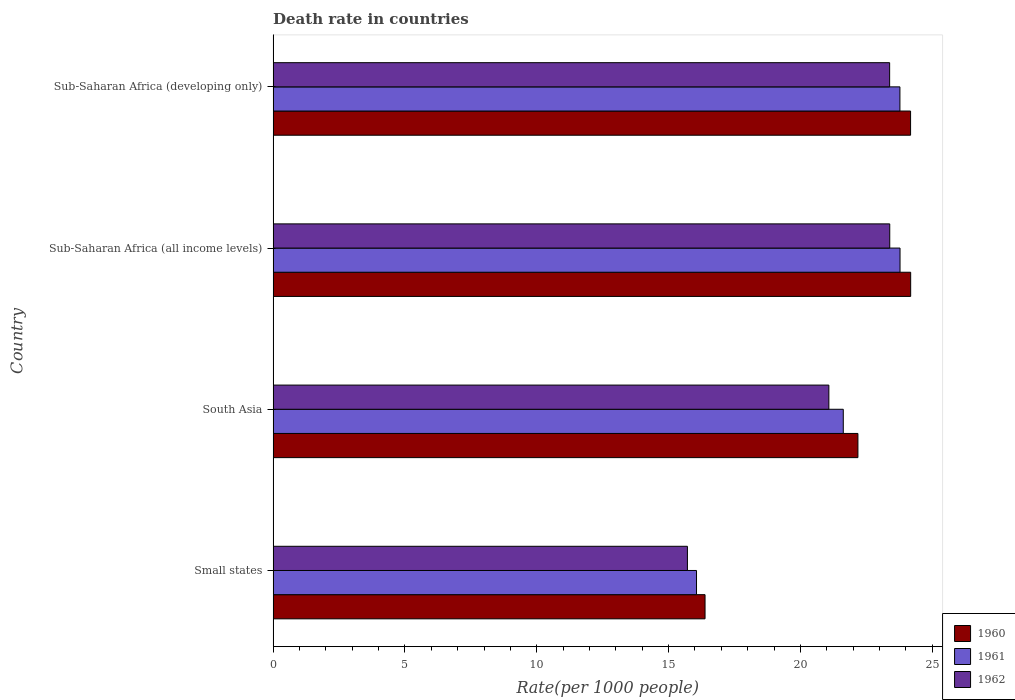How many different coloured bars are there?
Provide a succinct answer. 3. How many groups of bars are there?
Give a very brief answer. 4. Are the number of bars on each tick of the Y-axis equal?
Make the answer very short. Yes. How many bars are there on the 1st tick from the top?
Give a very brief answer. 3. How many bars are there on the 1st tick from the bottom?
Give a very brief answer. 3. What is the label of the 2nd group of bars from the top?
Provide a succinct answer. Sub-Saharan Africa (all income levels). What is the death rate in 1962 in Small states?
Your response must be concise. 15.72. Across all countries, what is the maximum death rate in 1960?
Your answer should be very brief. 24.18. Across all countries, what is the minimum death rate in 1961?
Offer a very short reply. 16.06. In which country was the death rate in 1961 maximum?
Offer a very short reply. Sub-Saharan Africa (all income levels). In which country was the death rate in 1960 minimum?
Ensure brevity in your answer.  Small states. What is the total death rate in 1962 in the graph?
Your answer should be compact. 83.58. What is the difference between the death rate in 1960 in South Asia and that in Sub-Saharan Africa (developing only)?
Provide a succinct answer. -2. What is the difference between the death rate in 1962 in Sub-Saharan Africa (all income levels) and the death rate in 1961 in Small states?
Keep it short and to the point. 7.33. What is the average death rate in 1961 per country?
Make the answer very short. 21.31. What is the difference between the death rate in 1960 and death rate in 1961 in Sub-Saharan Africa (all income levels)?
Ensure brevity in your answer.  0.4. What is the ratio of the death rate in 1962 in Small states to that in Sub-Saharan Africa (all income levels)?
Your answer should be very brief. 0.67. What is the difference between the highest and the second highest death rate in 1962?
Provide a succinct answer. 0. What is the difference between the highest and the lowest death rate in 1961?
Your answer should be very brief. 7.72. In how many countries, is the death rate in 1962 greater than the average death rate in 1962 taken over all countries?
Your answer should be compact. 3. What does the 1st bar from the top in Sub-Saharan Africa (developing only) represents?
Your answer should be very brief. 1962. What does the 3rd bar from the bottom in Small states represents?
Make the answer very short. 1962. How many bars are there?
Your response must be concise. 12. How many countries are there in the graph?
Your answer should be very brief. 4. What is the difference between two consecutive major ticks on the X-axis?
Give a very brief answer. 5. Are the values on the major ticks of X-axis written in scientific E-notation?
Provide a short and direct response. No. Does the graph contain grids?
Your answer should be compact. No. Where does the legend appear in the graph?
Provide a short and direct response. Bottom right. How many legend labels are there?
Offer a very short reply. 3. How are the legend labels stacked?
Give a very brief answer. Vertical. What is the title of the graph?
Make the answer very short. Death rate in countries. What is the label or title of the X-axis?
Provide a succinct answer. Rate(per 1000 people). What is the Rate(per 1000 people) of 1960 in Small states?
Offer a terse response. 16.38. What is the Rate(per 1000 people) of 1961 in Small states?
Make the answer very short. 16.06. What is the Rate(per 1000 people) in 1962 in Small states?
Ensure brevity in your answer.  15.72. What is the Rate(per 1000 people) of 1960 in South Asia?
Provide a succinct answer. 22.18. What is the Rate(per 1000 people) of 1961 in South Asia?
Make the answer very short. 21.63. What is the Rate(per 1000 people) of 1962 in South Asia?
Give a very brief answer. 21.08. What is the Rate(per 1000 people) of 1960 in Sub-Saharan Africa (all income levels)?
Your response must be concise. 24.18. What is the Rate(per 1000 people) in 1961 in Sub-Saharan Africa (all income levels)?
Offer a very short reply. 23.78. What is the Rate(per 1000 people) of 1962 in Sub-Saharan Africa (all income levels)?
Provide a succinct answer. 23.39. What is the Rate(per 1000 people) in 1960 in Sub-Saharan Africa (developing only)?
Give a very brief answer. 24.18. What is the Rate(per 1000 people) in 1961 in Sub-Saharan Africa (developing only)?
Your answer should be very brief. 23.78. What is the Rate(per 1000 people) of 1962 in Sub-Saharan Africa (developing only)?
Ensure brevity in your answer.  23.39. Across all countries, what is the maximum Rate(per 1000 people) of 1960?
Keep it short and to the point. 24.18. Across all countries, what is the maximum Rate(per 1000 people) in 1961?
Your answer should be compact. 23.78. Across all countries, what is the maximum Rate(per 1000 people) of 1962?
Provide a succinct answer. 23.39. Across all countries, what is the minimum Rate(per 1000 people) of 1960?
Offer a very short reply. 16.38. Across all countries, what is the minimum Rate(per 1000 people) in 1961?
Your answer should be very brief. 16.06. Across all countries, what is the minimum Rate(per 1000 people) in 1962?
Make the answer very short. 15.72. What is the total Rate(per 1000 people) of 1960 in the graph?
Give a very brief answer. 86.93. What is the total Rate(per 1000 people) of 1961 in the graph?
Offer a terse response. 85.25. What is the total Rate(per 1000 people) in 1962 in the graph?
Provide a succinct answer. 83.58. What is the difference between the Rate(per 1000 people) in 1960 in Small states and that in South Asia?
Your response must be concise. -5.8. What is the difference between the Rate(per 1000 people) of 1961 in Small states and that in South Asia?
Your answer should be very brief. -5.57. What is the difference between the Rate(per 1000 people) of 1962 in Small states and that in South Asia?
Provide a short and direct response. -5.37. What is the difference between the Rate(per 1000 people) in 1960 in Small states and that in Sub-Saharan Africa (all income levels)?
Keep it short and to the point. -7.8. What is the difference between the Rate(per 1000 people) of 1961 in Small states and that in Sub-Saharan Africa (all income levels)?
Your answer should be very brief. -7.72. What is the difference between the Rate(per 1000 people) of 1962 in Small states and that in Sub-Saharan Africa (all income levels)?
Provide a succinct answer. -7.68. What is the difference between the Rate(per 1000 people) of 1960 in Small states and that in Sub-Saharan Africa (developing only)?
Your answer should be compact. -7.8. What is the difference between the Rate(per 1000 people) of 1961 in Small states and that in Sub-Saharan Africa (developing only)?
Ensure brevity in your answer.  -7.72. What is the difference between the Rate(per 1000 people) in 1962 in Small states and that in Sub-Saharan Africa (developing only)?
Provide a short and direct response. -7.67. What is the difference between the Rate(per 1000 people) in 1960 in South Asia and that in Sub-Saharan Africa (all income levels)?
Offer a very short reply. -2. What is the difference between the Rate(per 1000 people) of 1961 in South Asia and that in Sub-Saharan Africa (all income levels)?
Ensure brevity in your answer.  -2.15. What is the difference between the Rate(per 1000 people) in 1962 in South Asia and that in Sub-Saharan Africa (all income levels)?
Make the answer very short. -2.31. What is the difference between the Rate(per 1000 people) in 1960 in South Asia and that in Sub-Saharan Africa (developing only)?
Your response must be concise. -2. What is the difference between the Rate(per 1000 people) of 1961 in South Asia and that in Sub-Saharan Africa (developing only)?
Ensure brevity in your answer.  -2.15. What is the difference between the Rate(per 1000 people) in 1962 in South Asia and that in Sub-Saharan Africa (developing only)?
Provide a short and direct response. -2.31. What is the difference between the Rate(per 1000 people) of 1960 in Sub-Saharan Africa (all income levels) and that in Sub-Saharan Africa (developing only)?
Offer a very short reply. 0. What is the difference between the Rate(per 1000 people) of 1961 in Sub-Saharan Africa (all income levels) and that in Sub-Saharan Africa (developing only)?
Offer a very short reply. 0. What is the difference between the Rate(per 1000 people) of 1962 in Sub-Saharan Africa (all income levels) and that in Sub-Saharan Africa (developing only)?
Offer a terse response. 0. What is the difference between the Rate(per 1000 people) in 1960 in Small states and the Rate(per 1000 people) in 1961 in South Asia?
Provide a short and direct response. -5.24. What is the difference between the Rate(per 1000 people) of 1960 in Small states and the Rate(per 1000 people) of 1962 in South Asia?
Your answer should be very brief. -4.7. What is the difference between the Rate(per 1000 people) in 1961 in Small states and the Rate(per 1000 people) in 1962 in South Asia?
Keep it short and to the point. -5.02. What is the difference between the Rate(per 1000 people) in 1960 in Small states and the Rate(per 1000 people) in 1961 in Sub-Saharan Africa (all income levels)?
Offer a very short reply. -7.4. What is the difference between the Rate(per 1000 people) in 1960 in Small states and the Rate(per 1000 people) in 1962 in Sub-Saharan Africa (all income levels)?
Offer a terse response. -7.01. What is the difference between the Rate(per 1000 people) of 1961 in Small states and the Rate(per 1000 people) of 1962 in Sub-Saharan Africa (all income levels)?
Offer a terse response. -7.33. What is the difference between the Rate(per 1000 people) of 1960 in Small states and the Rate(per 1000 people) of 1961 in Sub-Saharan Africa (developing only)?
Your answer should be compact. -7.39. What is the difference between the Rate(per 1000 people) in 1960 in Small states and the Rate(per 1000 people) in 1962 in Sub-Saharan Africa (developing only)?
Your answer should be compact. -7. What is the difference between the Rate(per 1000 people) in 1961 in Small states and the Rate(per 1000 people) in 1962 in Sub-Saharan Africa (developing only)?
Give a very brief answer. -7.33. What is the difference between the Rate(per 1000 people) in 1960 in South Asia and the Rate(per 1000 people) in 1961 in Sub-Saharan Africa (all income levels)?
Provide a succinct answer. -1.6. What is the difference between the Rate(per 1000 people) of 1960 in South Asia and the Rate(per 1000 people) of 1962 in Sub-Saharan Africa (all income levels)?
Give a very brief answer. -1.21. What is the difference between the Rate(per 1000 people) in 1961 in South Asia and the Rate(per 1000 people) in 1962 in Sub-Saharan Africa (all income levels)?
Keep it short and to the point. -1.76. What is the difference between the Rate(per 1000 people) in 1960 in South Asia and the Rate(per 1000 people) in 1961 in Sub-Saharan Africa (developing only)?
Keep it short and to the point. -1.59. What is the difference between the Rate(per 1000 people) in 1960 in South Asia and the Rate(per 1000 people) in 1962 in Sub-Saharan Africa (developing only)?
Make the answer very short. -1.2. What is the difference between the Rate(per 1000 people) in 1961 in South Asia and the Rate(per 1000 people) in 1962 in Sub-Saharan Africa (developing only)?
Ensure brevity in your answer.  -1.76. What is the difference between the Rate(per 1000 people) in 1960 in Sub-Saharan Africa (all income levels) and the Rate(per 1000 people) in 1961 in Sub-Saharan Africa (developing only)?
Make the answer very short. 0.41. What is the difference between the Rate(per 1000 people) in 1960 in Sub-Saharan Africa (all income levels) and the Rate(per 1000 people) in 1962 in Sub-Saharan Africa (developing only)?
Offer a very short reply. 0.8. What is the difference between the Rate(per 1000 people) of 1961 in Sub-Saharan Africa (all income levels) and the Rate(per 1000 people) of 1962 in Sub-Saharan Africa (developing only)?
Provide a short and direct response. 0.39. What is the average Rate(per 1000 people) in 1960 per country?
Provide a succinct answer. 21.73. What is the average Rate(per 1000 people) in 1961 per country?
Give a very brief answer. 21.31. What is the average Rate(per 1000 people) of 1962 per country?
Provide a short and direct response. 20.89. What is the difference between the Rate(per 1000 people) in 1960 and Rate(per 1000 people) in 1961 in Small states?
Make the answer very short. 0.32. What is the difference between the Rate(per 1000 people) in 1960 and Rate(per 1000 people) in 1962 in Small states?
Offer a terse response. 0.67. What is the difference between the Rate(per 1000 people) in 1961 and Rate(per 1000 people) in 1962 in Small states?
Your answer should be very brief. 0.35. What is the difference between the Rate(per 1000 people) in 1960 and Rate(per 1000 people) in 1961 in South Asia?
Offer a very short reply. 0.56. What is the difference between the Rate(per 1000 people) in 1960 and Rate(per 1000 people) in 1962 in South Asia?
Keep it short and to the point. 1.1. What is the difference between the Rate(per 1000 people) in 1961 and Rate(per 1000 people) in 1962 in South Asia?
Offer a very short reply. 0.55. What is the difference between the Rate(per 1000 people) of 1960 and Rate(per 1000 people) of 1961 in Sub-Saharan Africa (all income levels)?
Offer a terse response. 0.4. What is the difference between the Rate(per 1000 people) in 1960 and Rate(per 1000 people) in 1962 in Sub-Saharan Africa (all income levels)?
Offer a very short reply. 0.79. What is the difference between the Rate(per 1000 people) in 1961 and Rate(per 1000 people) in 1962 in Sub-Saharan Africa (all income levels)?
Offer a terse response. 0.39. What is the difference between the Rate(per 1000 people) in 1960 and Rate(per 1000 people) in 1961 in Sub-Saharan Africa (developing only)?
Offer a very short reply. 0.4. What is the difference between the Rate(per 1000 people) in 1960 and Rate(per 1000 people) in 1962 in Sub-Saharan Africa (developing only)?
Provide a short and direct response. 0.79. What is the difference between the Rate(per 1000 people) in 1961 and Rate(per 1000 people) in 1962 in Sub-Saharan Africa (developing only)?
Offer a very short reply. 0.39. What is the ratio of the Rate(per 1000 people) in 1960 in Small states to that in South Asia?
Offer a terse response. 0.74. What is the ratio of the Rate(per 1000 people) in 1961 in Small states to that in South Asia?
Your answer should be very brief. 0.74. What is the ratio of the Rate(per 1000 people) of 1962 in Small states to that in South Asia?
Offer a terse response. 0.75. What is the ratio of the Rate(per 1000 people) of 1960 in Small states to that in Sub-Saharan Africa (all income levels)?
Give a very brief answer. 0.68. What is the ratio of the Rate(per 1000 people) in 1961 in Small states to that in Sub-Saharan Africa (all income levels)?
Keep it short and to the point. 0.68. What is the ratio of the Rate(per 1000 people) in 1962 in Small states to that in Sub-Saharan Africa (all income levels)?
Give a very brief answer. 0.67. What is the ratio of the Rate(per 1000 people) of 1960 in Small states to that in Sub-Saharan Africa (developing only)?
Provide a succinct answer. 0.68. What is the ratio of the Rate(per 1000 people) of 1961 in Small states to that in Sub-Saharan Africa (developing only)?
Your answer should be very brief. 0.68. What is the ratio of the Rate(per 1000 people) in 1962 in Small states to that in Sub-Saharan Africa (developing only)?
Provide a short and direct response. 0.67. What is the ratio of the Rate(per 1000 people) in 1960 in South Asia to that in Sub-Saharan Africa (all income levels)?
Offer a terse response. 0.92. What is the ratio of the Rate(per 1000 people) of 1961 in South Asia to that in Sub-Saharan Africa (all income levels)?
Your answer should be very brief. 0.91. What is the ratio of the Rate(per 1000 people) in 1962 in South Asia to that in Sub-Saharan Africa (all income levels)?
Your response must be concise. 0.9. What is the ratio of the Rate(per 1000 people) of 1960 in South Asia to that in Sub-Saharan Africa (developing only)?
Ensure brevity in your answer.  0.92. What is the ratio of the Rate(per 1000 people) in 1961 in South Asia to that in Sub-Saharan Africa (developing only)?
Ensure brevity in your answer.  0.91. What is the ratio of the Rate(per 1000 people) of 1962 in South Asia to that in Sub-Saharan Africa (developing only)?
Offer a terse response. 0.9. What is the ratio of the Rate(per 1000 people) of 1960 in Sub-Saharan Africa (all income levels) to that in Sub-Saharan Africa (developing only)?
Ensure brevity in your answer.  1. What is the difference between the highest and the second highest Rate(per 1000 people) of 1960?
Ensure brevity in your answer.  0. What is the difference between the highest and the second highest Rate(per 1000 people) in 1961?
Offer a very short reply. 0. What is the difference between the highest and the second highest Rate(per 1000 people) in 1962?
Your response must be concise. 0. What is the difference between the highest and the lowest Rate(per 1000 people) in 1960?
Provide a succinct answer. 7.8. What is the difference between the highest and the lowest Rate(per 1000 people) in 1961?
Your answer should be compact. 7.72. What is the difference between the highest and the lowest Rate(per 1000 people) of 1962?
Give a very brief answer. 7.68. 